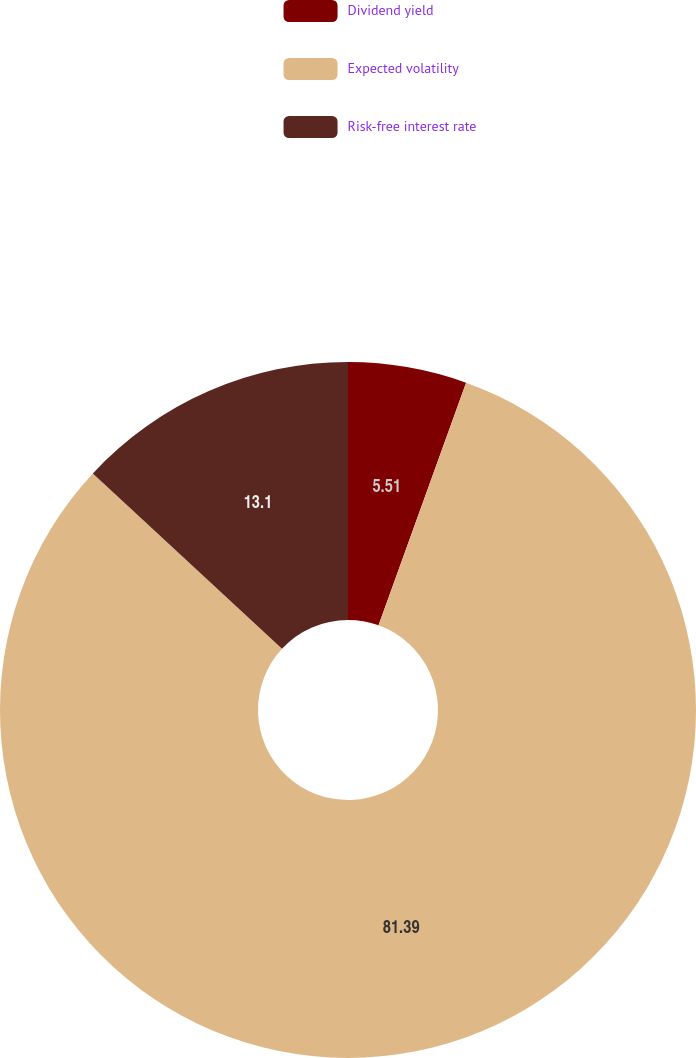Convert chart. <chart><loc_0><loc_0><loc_500><loc_500><pie_chart><fcel>Dividend yield<fcel>Expected volatility<fcel>Risk-free interest rate<nl><fcel>5.51%<fcel>81.39%<fcel>13.1%<nl></chart> 